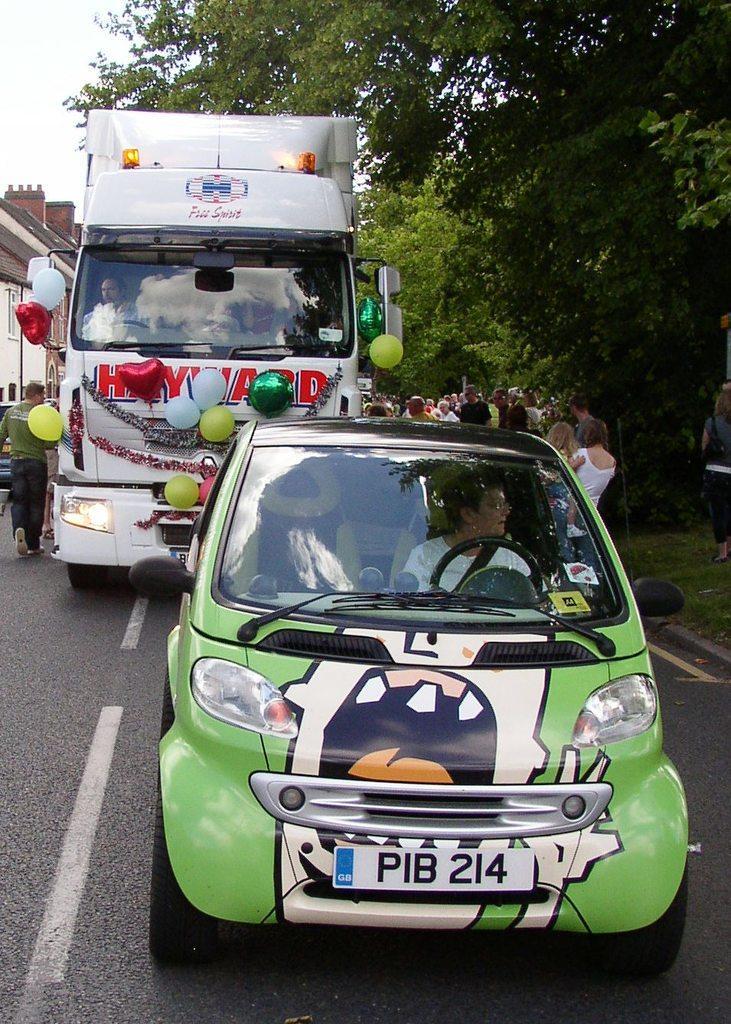How would you summarize this image in a sentence or two? The picture is taken on streets of a city. In the foreground of the picture there is a car and a truck, to the truck there are balloons. In the center of the background there are people and trees. On the right there are trees. On the left there are buildings and people walking on the road. 